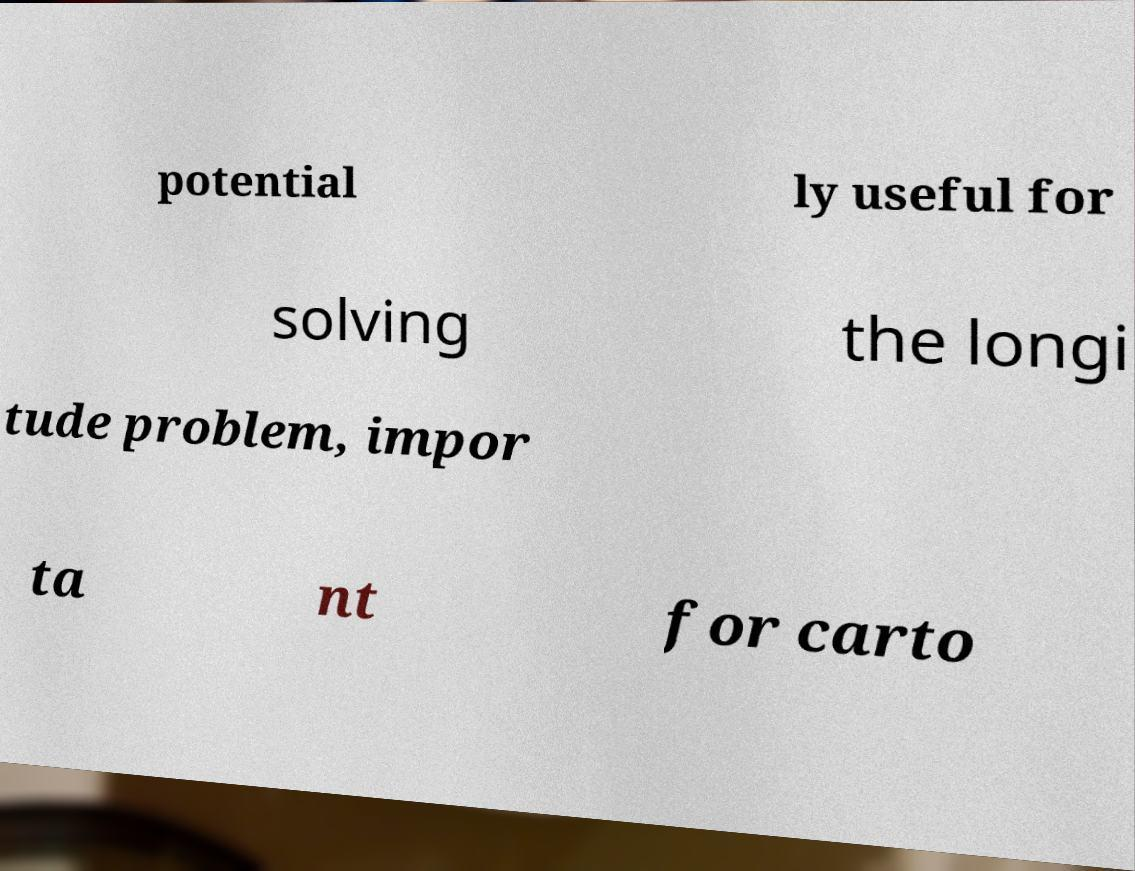There's text embedded in this image that I need extracted. Can you transcribe it verbatim? potential ly useful for solving the longi tude problem, impor ta nt for carto 